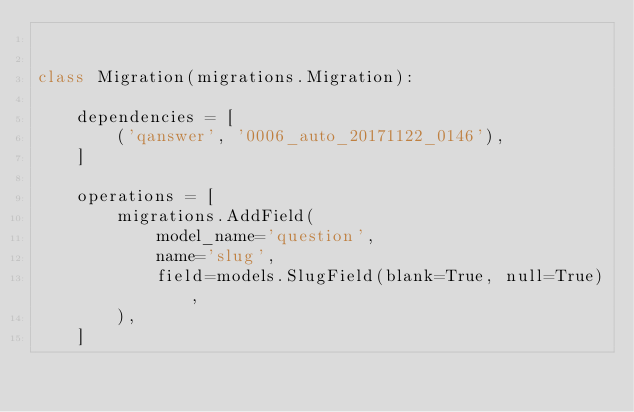<code> <loc_0><loc_0><loc_500><loc_500><_Python_>

class Migration(migrations.Migration):

    dependencies = [
        ('qanswer', '0006_auto_20171122_0146'),
    ]

    operations = [
        migrations.AddField(
            model_name='question',
            name='slug',
            field=models.SlugField(blank=True, null=True),
        ),
    ]
</code> 